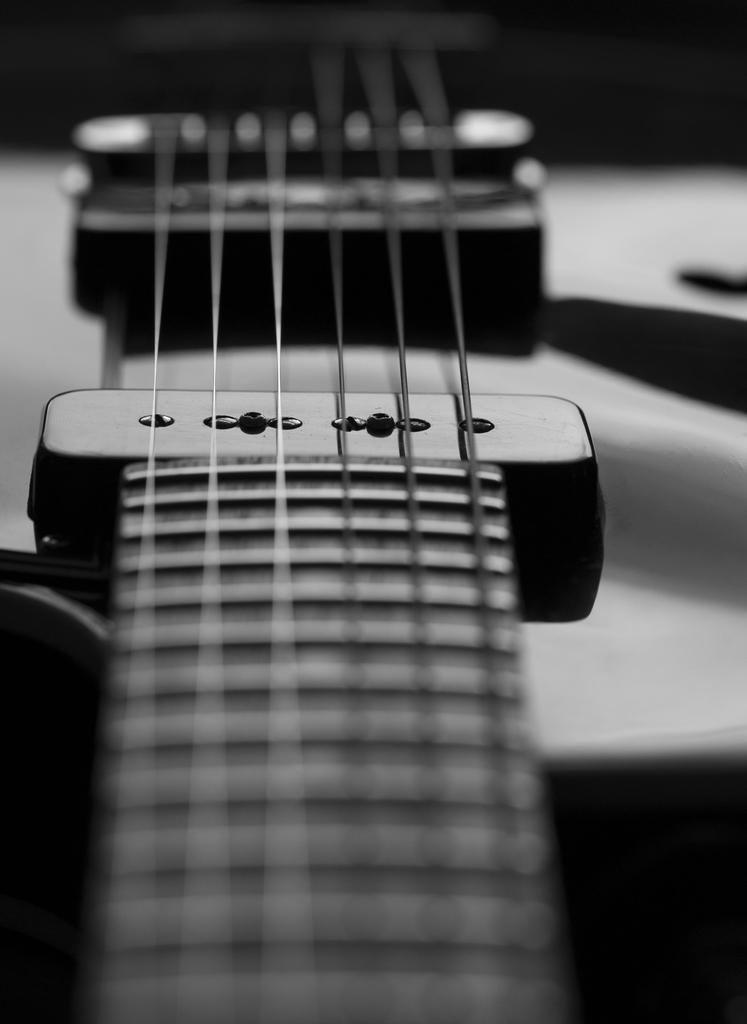What musical instrument is present in the image? There is a guitar in the image. What feature of the guitar is mentioned in the facts? The guitar has strings. What type of cake is being played on the guitar in the image? There is no cake present in the image, and the guitar is not being played on. 